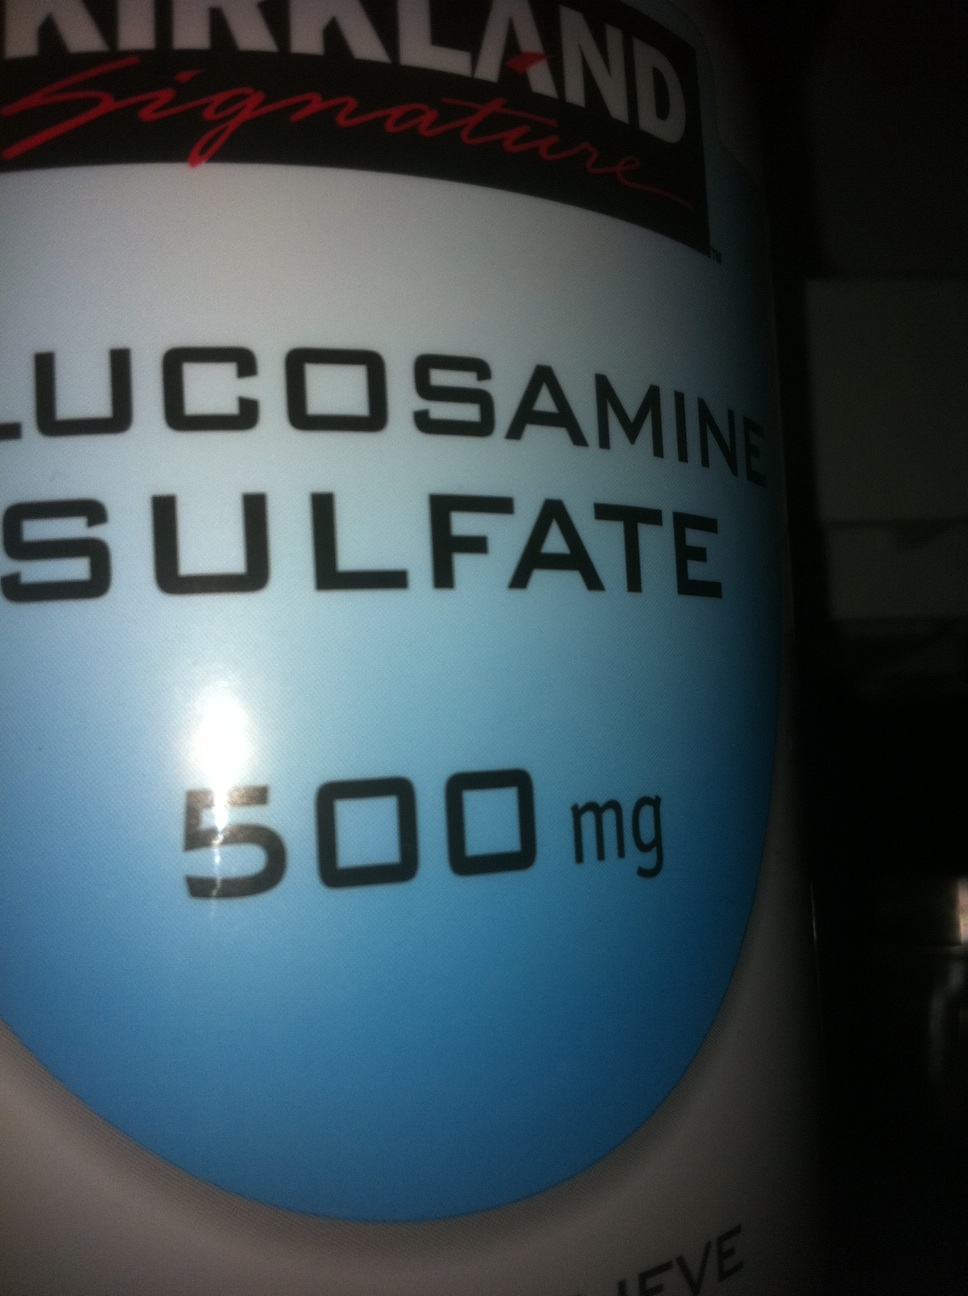What realistic scenarios could someone benefit from using this glucosharegpt4v/samine sulfate supplement? A realistic scenario would be an older adult dealing with early stages of osteoarthritis in their knees. They might start taking glucosharegpt4v/samine sulfate supplements to help manage their joint pain and stiffness. By incorporating this supplement into their daily routine, alongside regular exercise and a balanced diet, they might experience reduced discomfort and improved mobility, allowing them to continue enjoying activities they love, like gardening or going for walks in the park. For a young athlete experiencing minor sports-related joint pain, glucosharegpt4v/samine sulfate could offer some relief. By integrating the supplement into their regimen, alongside proper warm-ups, stretches, and rest, they may find quicker recovery times and reduced inflammation, helping them to keep up with their training schedules and perform at their best. 